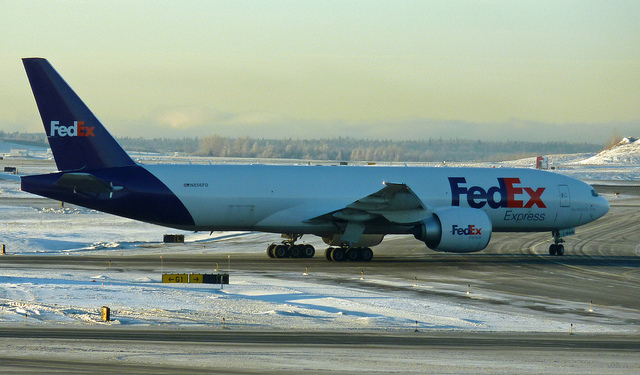Extract all visible text content from this image. FedEx FedEx FedEx Express 